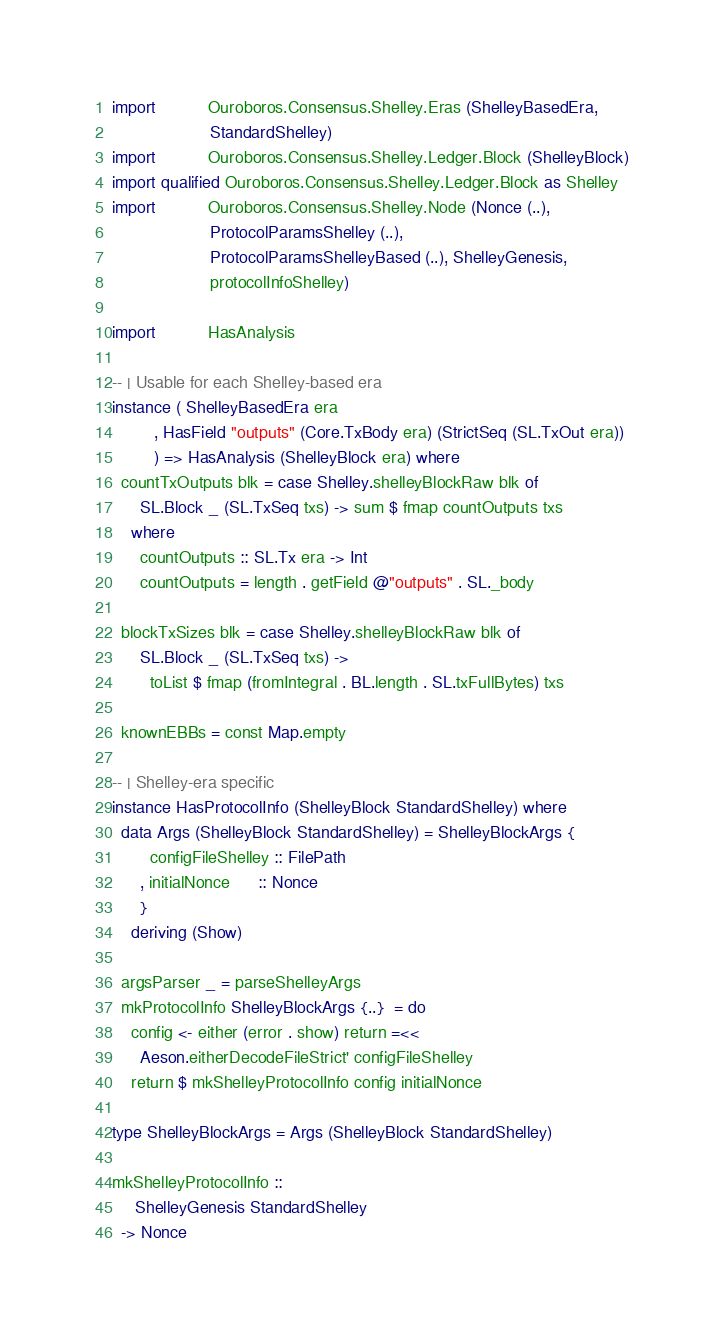<code> <loc_0><loc_0><loc_500><loc_500><_Haskell_>import           Ouroboros.Consensus.Shelley.Eras (ShelleyBasedEra,
                     StandardShelley)
import           Ouroboros.Consensus.Shelley.Ledger.Block (ShelleyBlock)
import qualified Ouroboros.Consensus.Shelley.Ledger.Block as Shelley
import           Ouroboros.Consensus.Shelley.Node (Nonce (..),
                     ProtocolParamsShelley (..),
                     ProtocolParamsShelleyBased (..), ShelleyGenesis,
                     protocolInfoShelley)

import           HasAnalysis

-- | Usable for each Shelley-based era
instance ( ShelleyBasedEra era
         , HasField "outputs" (Core.TxBody era) (StrictSeq (SL.TxOut era))
         ) => HasAnalysis (ShelleyBlock era) where
  countTxOutputs blk = case Shelley.shelleyBlockRaw blk of
      SL.Block _ (SL.TxSeq txs) -> sum $ fmap countOutputs txs
    where
      countOutputs :: SL.Tx era -> Int
      countOutputs = length . getField @"outputs" . SL._body

  blockTxSizes blk = case Shelley.shelleyBlockRaw blk of
      SL.Block _ (SL.TxSeq txs) ->
        toList $ fmap (fromIntegral . BL.length . SL.txFullBytes) txs

  knownEBBs = const Map.empty

-- | Shelley-era specific
instance HasProtocolInfo (ShelleyBlock StandardShelley) where
  data Args (ShelleyBlock StandardShelley) = ShelleyBlockArgs {
        configFileShelley :: FilePath
      , initialNonce      :: Nonce
      }
    deriving (Show)

  argsParser _ = parseShelleyArgs
  mkProtocolInfo ShelleyBlockArgs {..}  = do
    config <- either (error . show) return =<<
      Aeson.eitherDecodeFileStrict' configFileShelley
    return $ mkShelleyProtocolInfo config initialNonce

type ShelleyBlockArgs = Args (ShelleyBlock StandardShelley)

mkShelleyProtocolInfo ::
     ShelleyGenesis StandardShelley
  -> Nonce</code> 